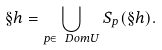Convert formula to latex. <formula><loc_0><loc_0><loc_500><loc_500>\S h = \bigcup _ { p \in \ D o m U } S _ { p } ( \S h ) .</formula> 